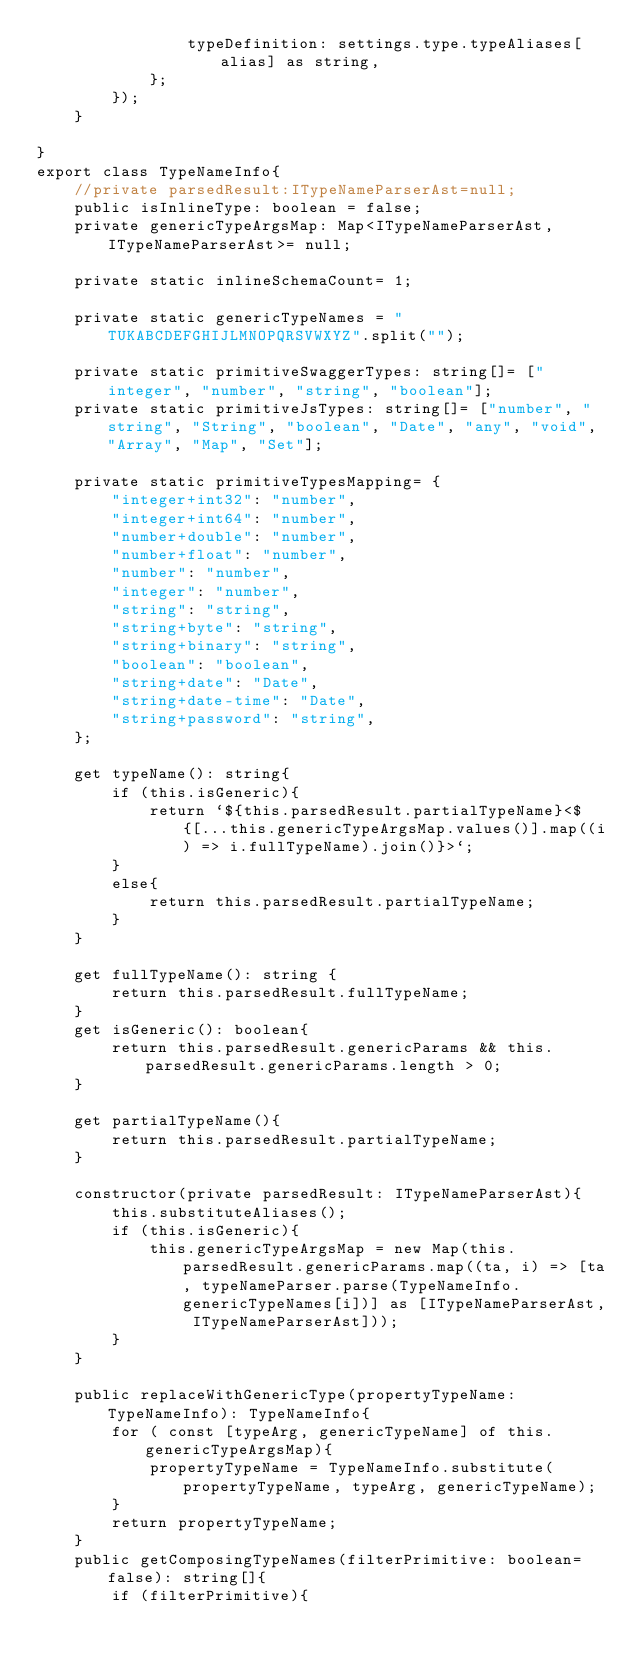<code> <loc_0><loc_0><loc_500><loc_500><_TypeScript_>                typeDefinition: settings.type.typeAliases[alias] as string,
            };
        });
    }

}
export class TypeNameInfo{
    //private parsedResult:ITypeNameParserAst=null;
    public isInlineType: boolean = false;
    private genericTypeArgsMap: Map<ITypeNameParserAst, ITypeNameParserAst>= null;

    private static inlineSchemaCount= 1;

    private static genericTypeNames = "TUKABCDEFGHIJLMNOPQRSVWXYZ".split("");

    private static primitiveSwaggerTypes: string[]= ["integer", "number", "string", "boolean"];
    private static primitiveJsTypes: string[]= ["number", "string", "String", "boolean", "Date", "any", "void", "Array", "Map", "Set"];

    private static primitiveTypesMapping= {
        "integer+int32": "number",
        "integer+int64": "number",
        "number+double": "number",
        "number+float": "number",
        "number": "number",
        "integer": "number",
        "string": "string",
        "string+byte": "string",
        "string+binary": "string",
        "boolean": "boolean",
        "string+date": "Date",
        "string+date-time": "Date",
        "string+password": "string",
    };

    get typeName(): string{
        if (this.isGeneric){
            return `${this.parsedResult.partialTypeName}<${[...this.genericTypeArgsMap.values()].map((i) => i.fullTypeName).join()}>`;
        }
        else{
            return this.parsedResult.partialTypeName;
        }
    }

    get fullTypeName(): string {
        return this.parsedResult.fullTypeName;
    }
    get isGeneric(): boolean{
        return this.parsedResult.genericParams && this.parsedResult.genericParams.length > 0;
    }

    get partialTypeName(){
        return this.parsedResult.partialTypeName;
    }

    constructor(private parsedResult: ITypeNameParserAst){
        this.substituteAliases();
        if (this.isGeneric){
            this.genericTypeArgsMap = new Map(this.parsedResult.genericParams.map((ta, i) => [ta, typeNameParser.parse(TypeNameInfo.genericTypeNames[i])] as [ITypeNameParserAst, ITypeNameParserAst]));
        }
    }

    public replaceWithGenericType(propertyTypeName: TypeNameInfo): TypeNameInfo{
        for ( const [typeArg, genericTypeName] of this.genericTypeArgsMap){
            propertyTypeName = TypeNameInfo.substitute(propertyTypeName, typeArg, genericTypeName);
        }
        return propertyTypeName;
    }
    public getComposingTypeNames(filterPrimitive: boolean= false): string[]{
        if (filterPrimitive){</code> 